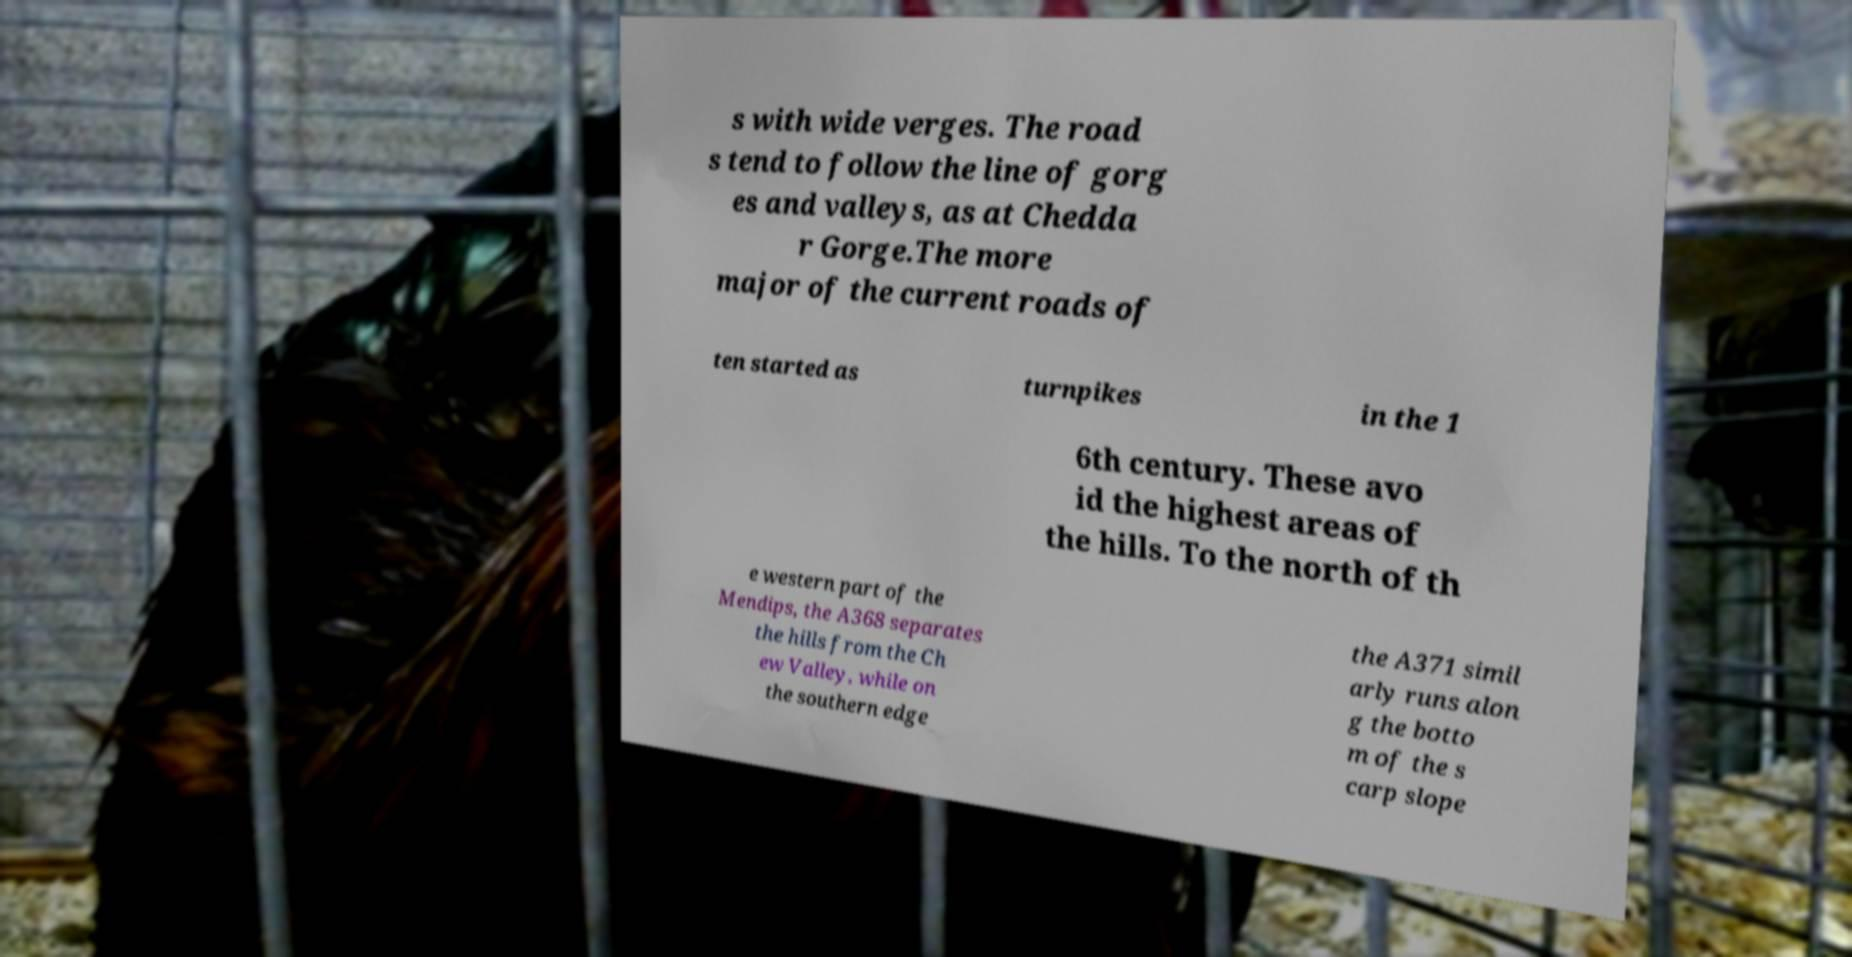Please read and relay the text visible in this image. What does it say? s with wide verges. The road s tend to follow the line of gorg es and valleys, as at Chedda r Gorge.The more major of the current roads of ten started as turnpikes in the 1 6th century. These avo id the highest areas of the hills. To the north of th e western part of the Mendips, the A368 separates the hills from the Ch ew Valley, while on the southern edge the A371 simil arly runs alon g the botto m of the s carp slope 